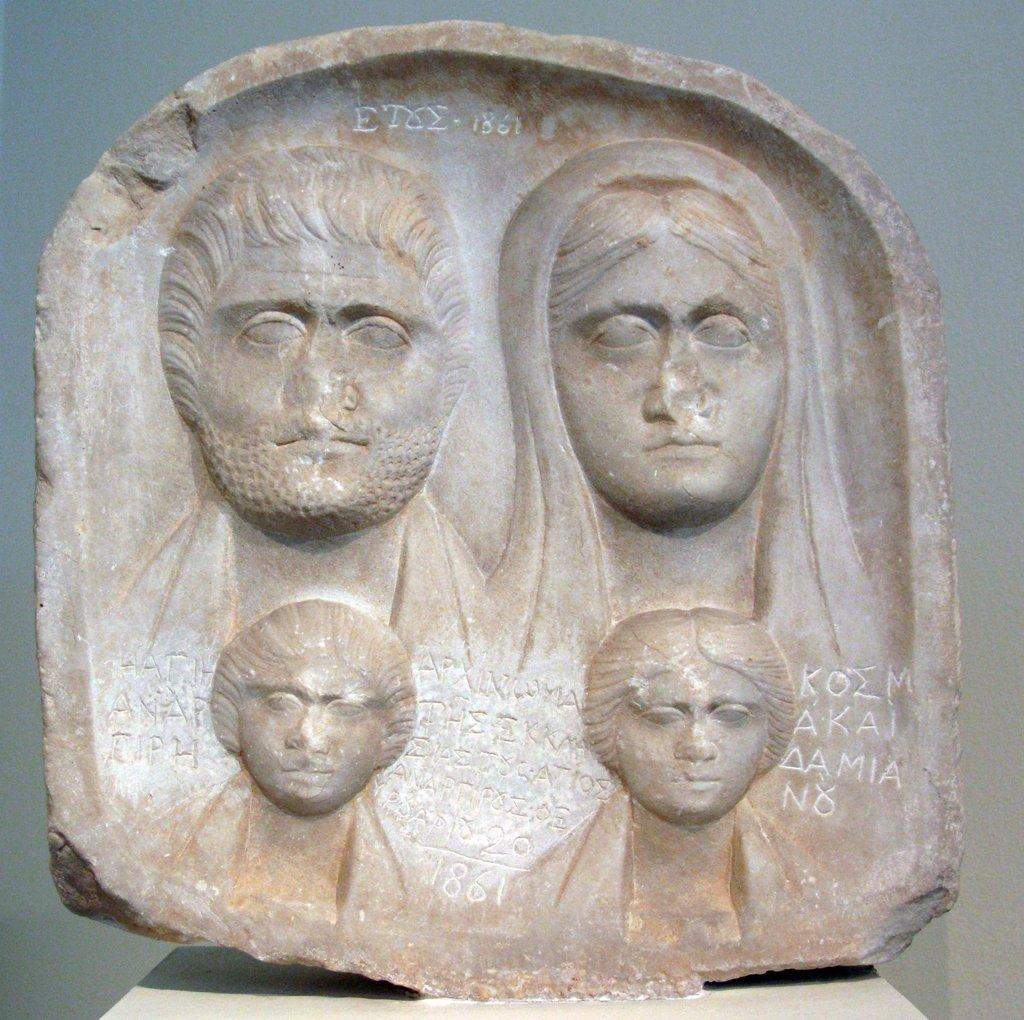What type of artwork is depicted in the image? There are relief or sculptures in the image. What material are the sculptures attached to? The sculptures are attached to a stone. What can be seen in the background of the image? There is a white wall in the background of the image. What is the name of the vessel that the sculptures are on in the image? There is no vessel present in the image; the sculptures are attached to a stone. 